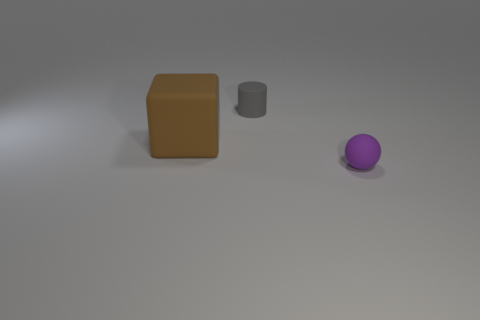Is there any other thing that has the same shape as the tiny gray thing?
Ensure brevity in your answer.  No. Are there any other things that have the same size as the block?
Give a very brief answer. No. The tiny purple object has what shape?
Ensure brevity in your answer.  Sphere. Is the number of tiny objects that are behind the big brown rubber block greater than the number of small red spheres?
Ensure brevity in your answer.  Yes. Are there any other matte things that have the same size as the purple object?
Make the answer very short. Yes. How big is the matte thing on the left side of the small matte cylinder?
Provide a succinct answer. Large. How big is the purple object?
Offer a terse response. Small. What number of cubes are either small gray things or purple rubber things?
Ensure brevity in your answer.  0. There is a cube that is made of the same material as the purple thing; what size is it?
Keep it short and to the point. Large. How many other big matte objects are the same color as the big object?
Provide a succinct answer. 0. 